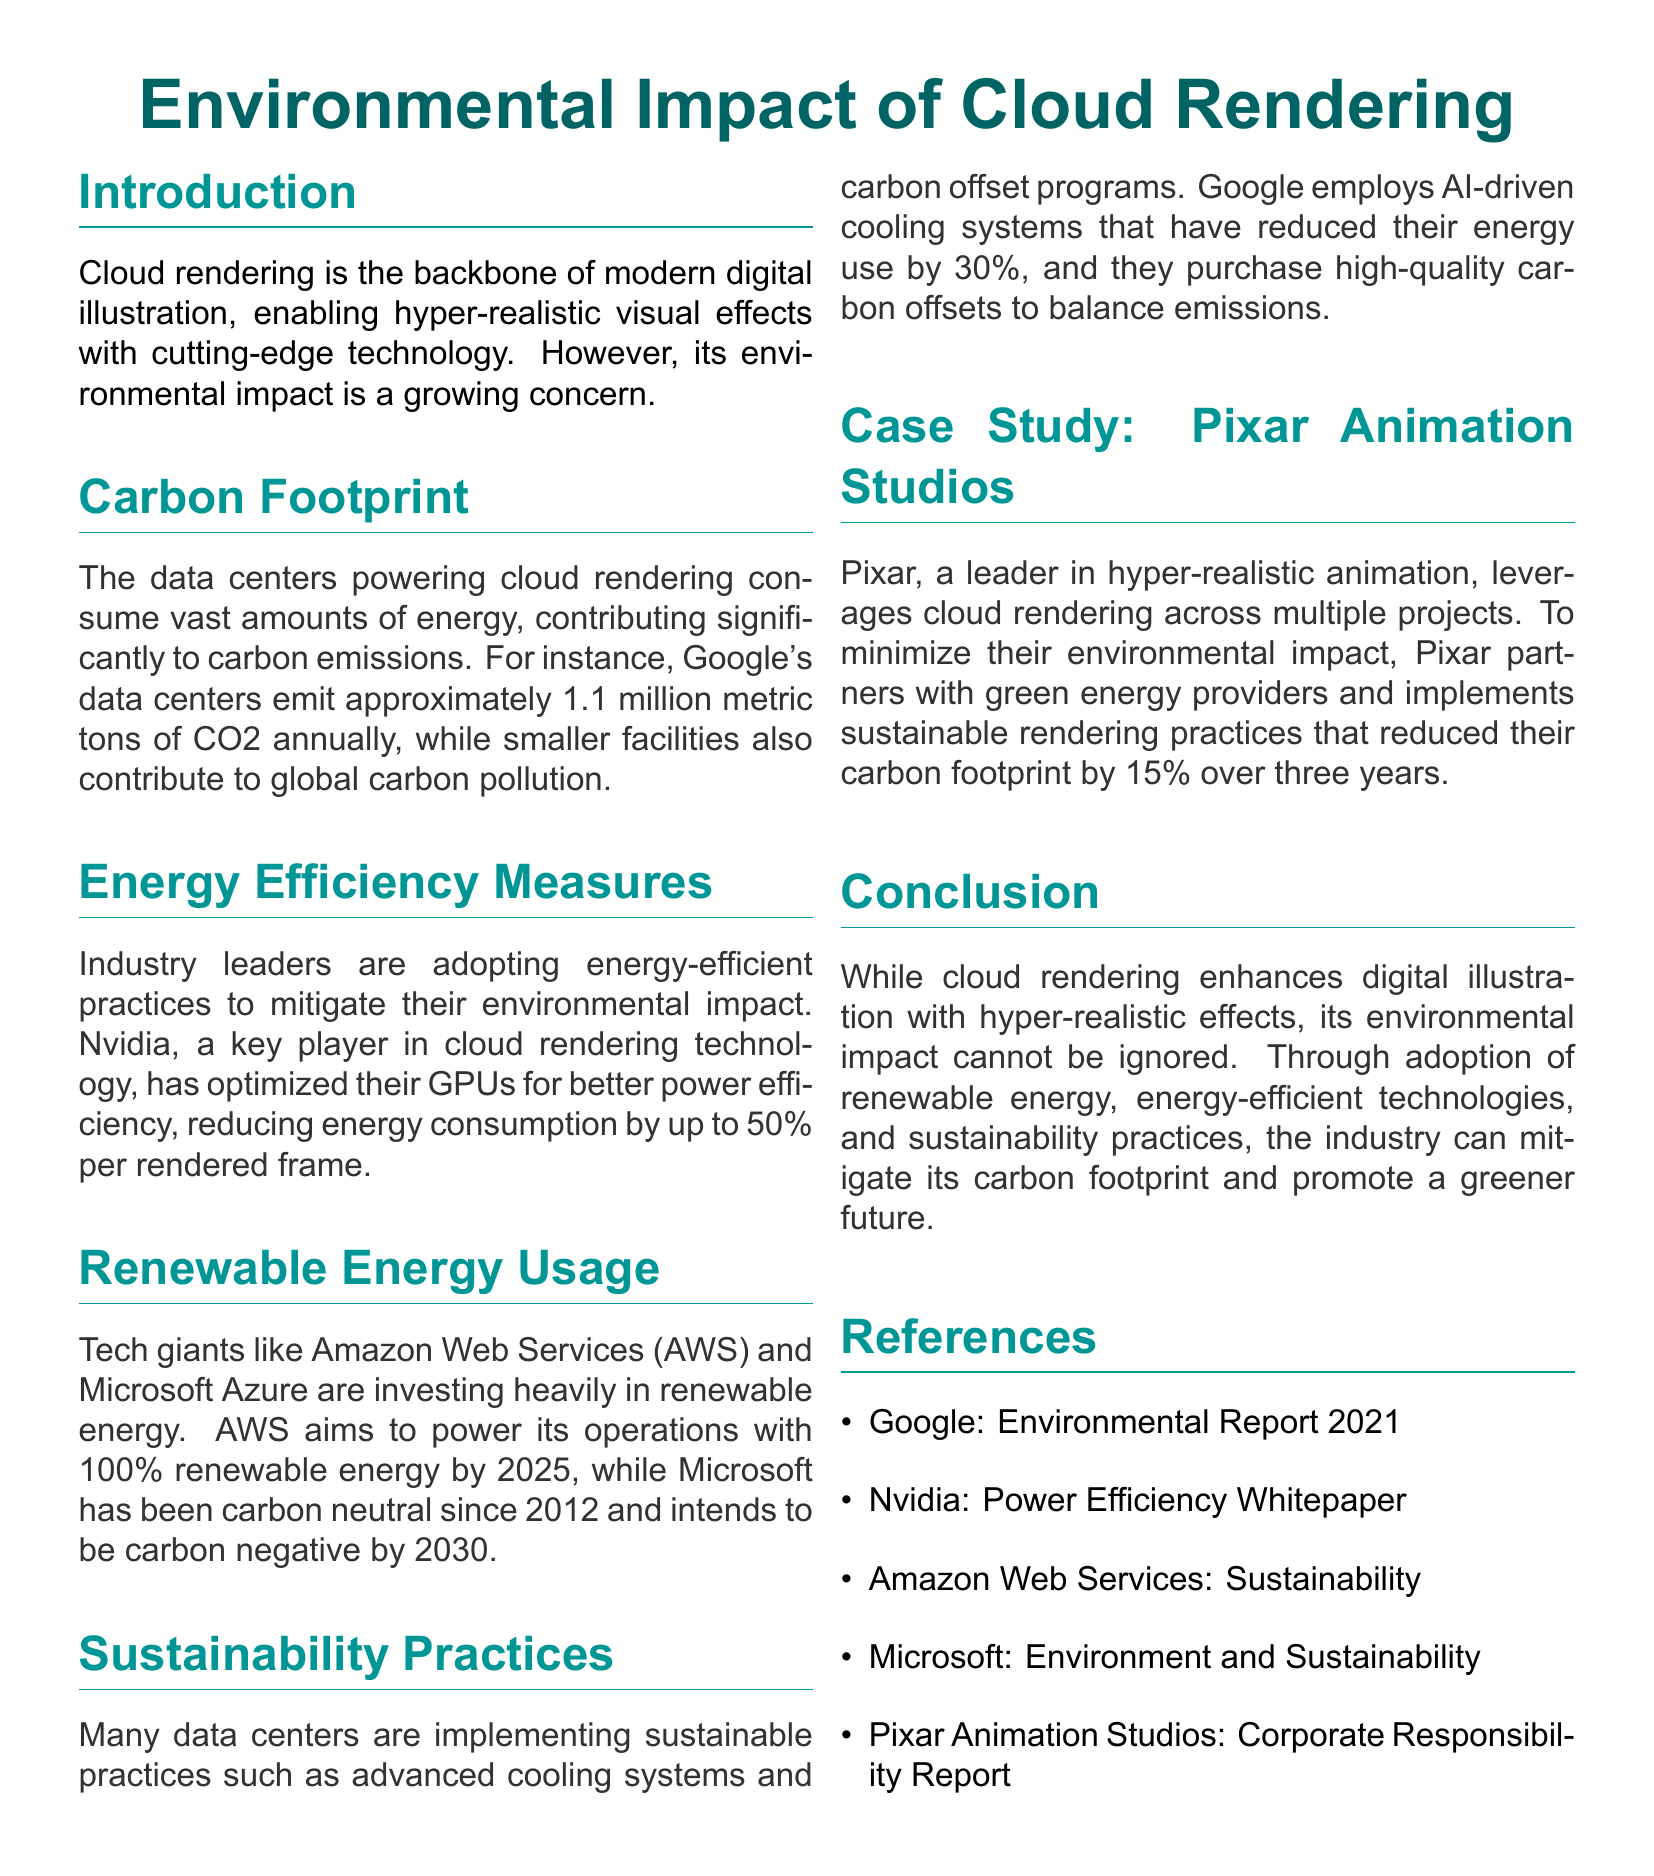What is the annual CO2 emission of Google's data centers? The document states that Google's data centers emit approximately 1.1 million metric tons of CO2 annually.
Answer: 1.1 million metric tons What percentage of energy reduction has Nvidia achieved per rendered frame? According to the document, Nvidia has optimized their GPUs for better power efficiency, reducing energy consumption by up to 50% per rendered frame.
Answer: 50% What year does AWS aim to power its operations with 100% renewable energy? The document mentions that AWS aims to achieve this goal by 2025.
Answer: 2025 What percentage reduction in carbon footprint has Pixar achieved over three years? The document states that Pixar has reduced their carbon footprint by 15% over three years.
Answer: 15% Which company implements AI-driven cooling systems to reduce energy use? The document specifies that Google employs AI-driven cooling systems.
Answer: Google What is the goal of Microsoft regarding carbon emissions by 2030? The document indicates that Microsoft intends to be carbon negative by 2030.
Answer: Carbon negative Which green practice does Google engage in to balance emissions? The document mentions that Google purchases high-quality carbon offsets.
Answer: Carbon offsets Which animation studio partners with green energy providers? According to the document, Pixar partners with green energy providers.
Answer: Pixar 